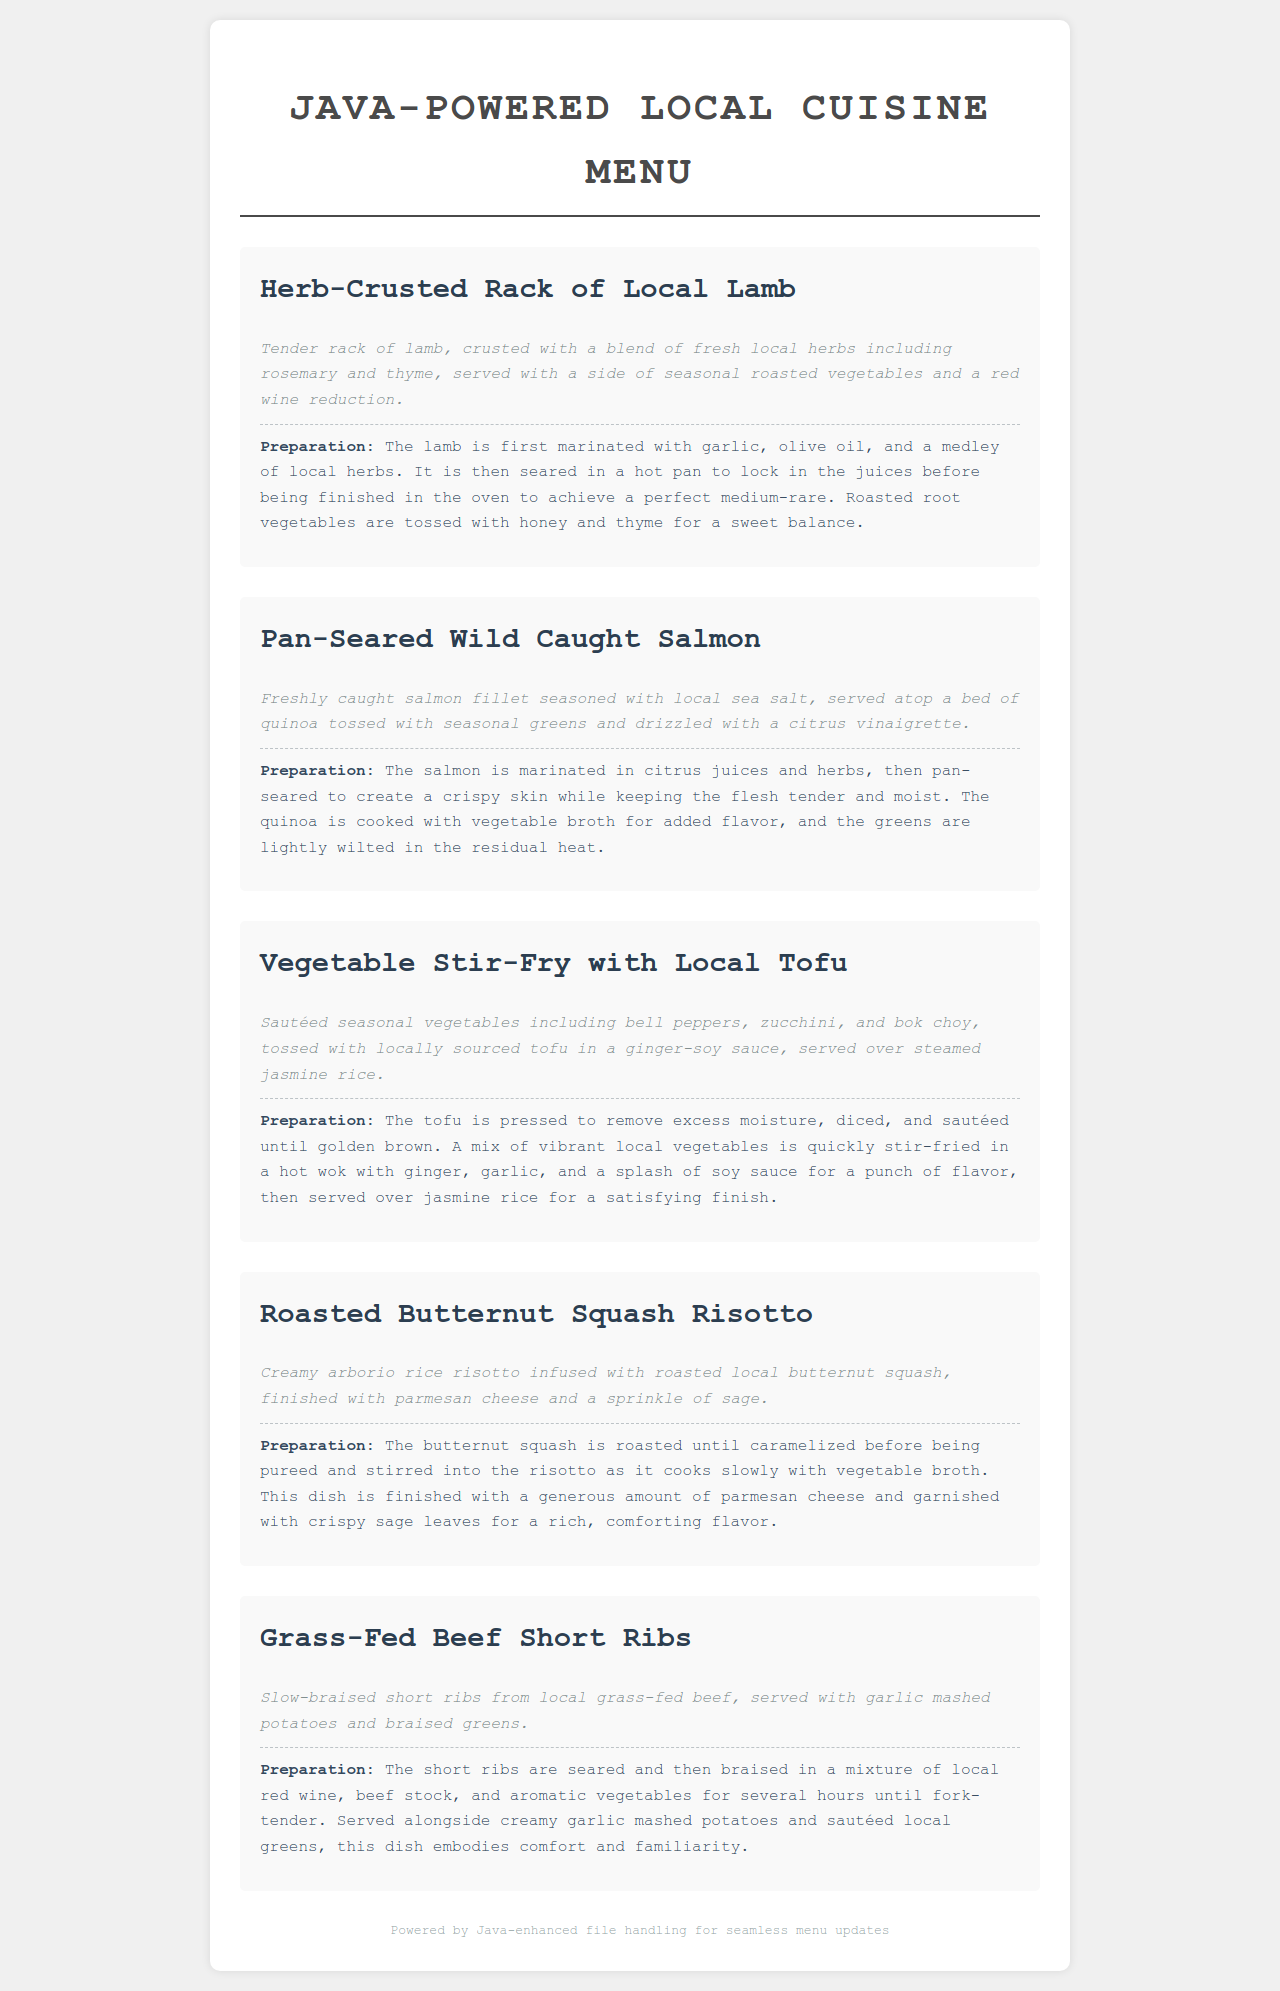What is the first main course option listed? The first main course option listed in the menu is "Herb-Crusted Rack of Local Lamb."
Answer: Herb-Crusted Rack of Local Lamb What type of fish is served in the second dish? The second dish is a "Pan-Seared Wild Caught Salmon," indicating that salmon is the type of fish served.
Answer: Salmon How is the tofu prepared in the vegetable stir-fry? The tofu is pressed to remove excess moisture, diced, and sautéed until golden brown, as stated in the preparation method.
Answer: Sautéed until golden brown What seasonal vegetables are included in the vegetable stir-fry? The dish description mentions sautéed seasonal vegetables including bell peppers, zucchini, and bok choy.
Answer: Bell peppers, zucchini, and bok choy What two sides are served with the Grass-Fed Beef Short Ribs? The preparation method specifies that it is served with garlic mashed potatoes and braised greens.
Answer: Garlic mashed potatoes and braised greens What is the primary ingredient in the Roasted Butternut Squash Risotto? The main ingredient highlighted in the risotto is roasted local butternut squash, according to the description.
Answer: Roasted local butternut squash How is the salmon prepared before being served? The preparation method describes the salmon as marinated in citrus juices and herbs before being pan-seared.
Answer: Marinated in citrus juices and herbs What type of rice is used in the risotto dish? The document specifies that the risotto is made with arborio rice, which is a key ingredient.
Answer: Arborio rice 